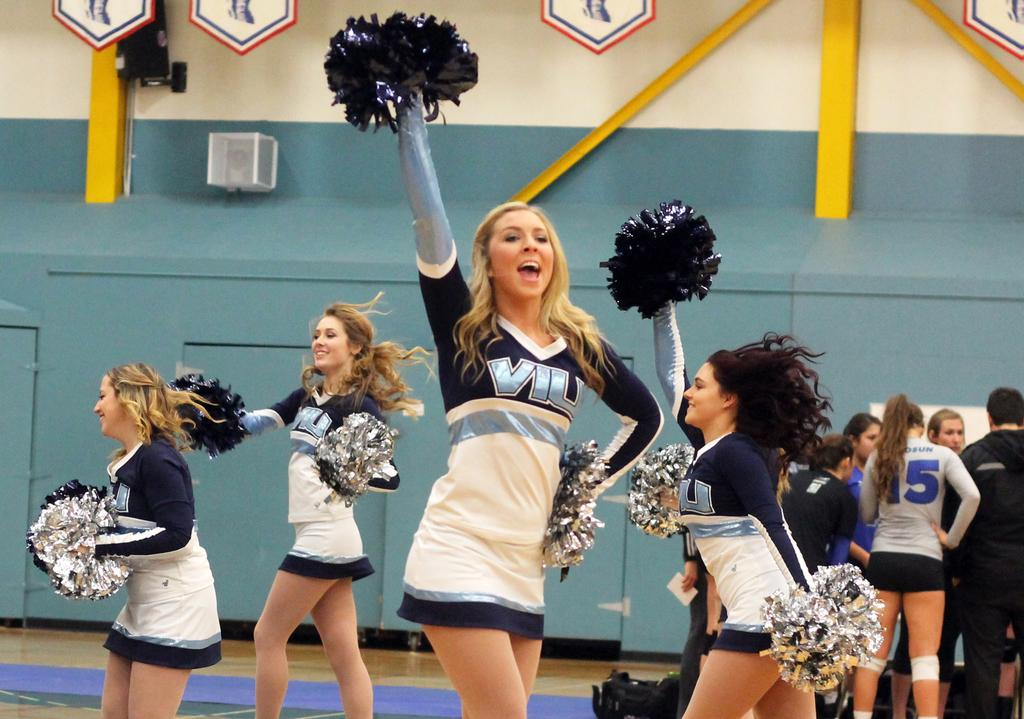<image>
Share a concise interpretation of the image provided. The VIU cheerleaders are waving their pom poms. 